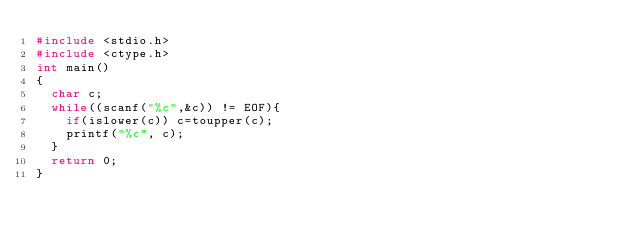<code> <loc_0><loc_0><loc_500><loc_500><_C_>#include <stdio.h>
#include <ctype.h>
int main()
{
  char c;
  while((scanf("%c",&c)) != EOF){
    if(islower(c)) c=toupper(c);
    printf("%c", c);
  }
  return 0;
}</code> 